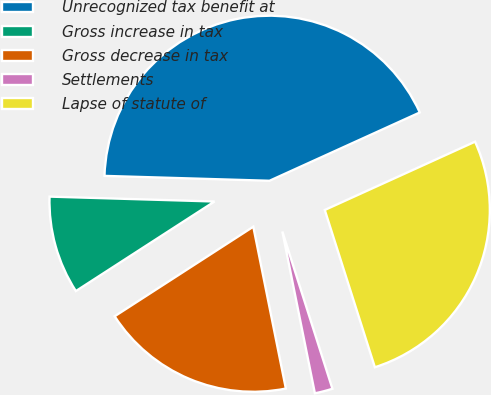Convert chart to OTSL. <chart><loc_0><loc_0><loc_500><loc_500><pie_chart><fcel>Unrecognized tax benefit at<fcel>Gross increase in tax<fcel>Gross decrease in tax<fcel>Settlements<fcel>Lapse of statute of<nl><fcel>42.74%<fcel>9.6%<fcel>19.03%<fcel>1.75%<fcel>26.88%<nl></chart> 